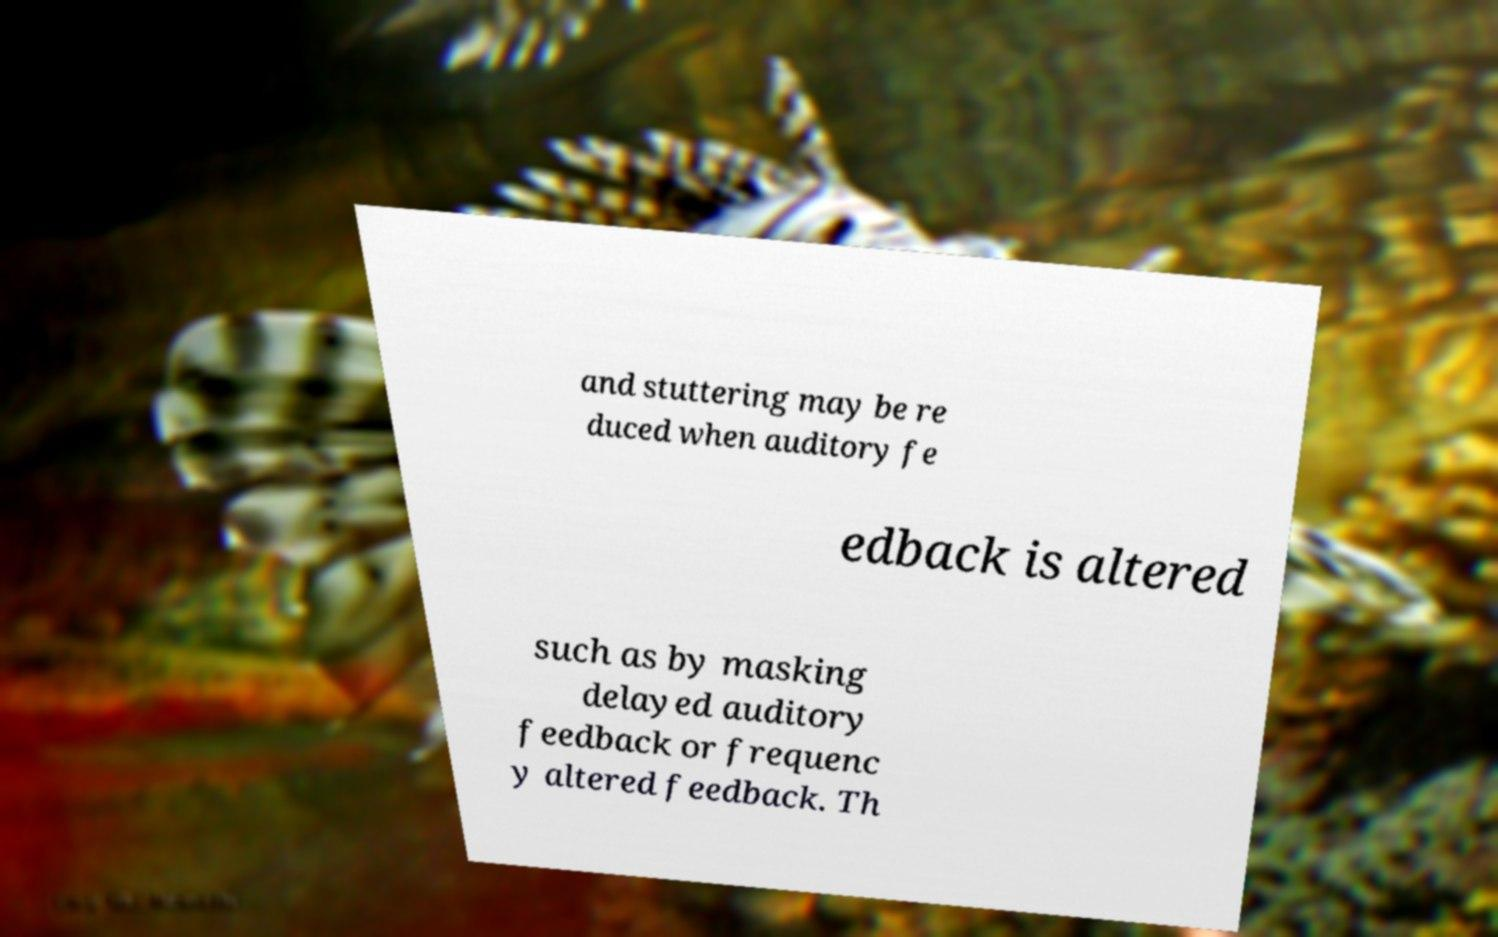I need the written content from this picture converted into text. Can you do that? and stuttering may be re duced when auditory fe edback is altered such as by masking delayed auditory feedback or frequenc y altered feedback. Th 